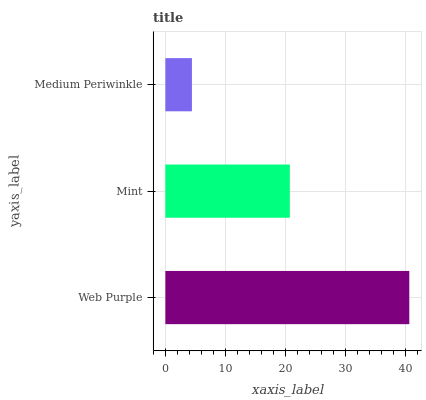Is Medium Periwinkle the minimum?
Answer yes or no. Yes. Is Web Purple the maximum?
Answer yes or no. Yes. Is Mint the minimum?
Answer yes or no. No. Is Mint the maximum?
Answer yes or no. No. Is Web Purple greater than Mint?
Answer yes or no. Yes. Is Mint less than Web Purple?
Answer yes or no. Yes. Is Mint greater than Web Purple?
Answer yes or no. No. Is Web Purple less than Mint?
Answer yes or no. No. Is Mint the high median?
Answer yes or no. Yes. Is Mint the low median?
Answer yes or no. Yes. Is Medium Periwinkle the high median?
Answer yes or no. No. Is Medium Periwinkle the low median?
Answer yes or no. No. 